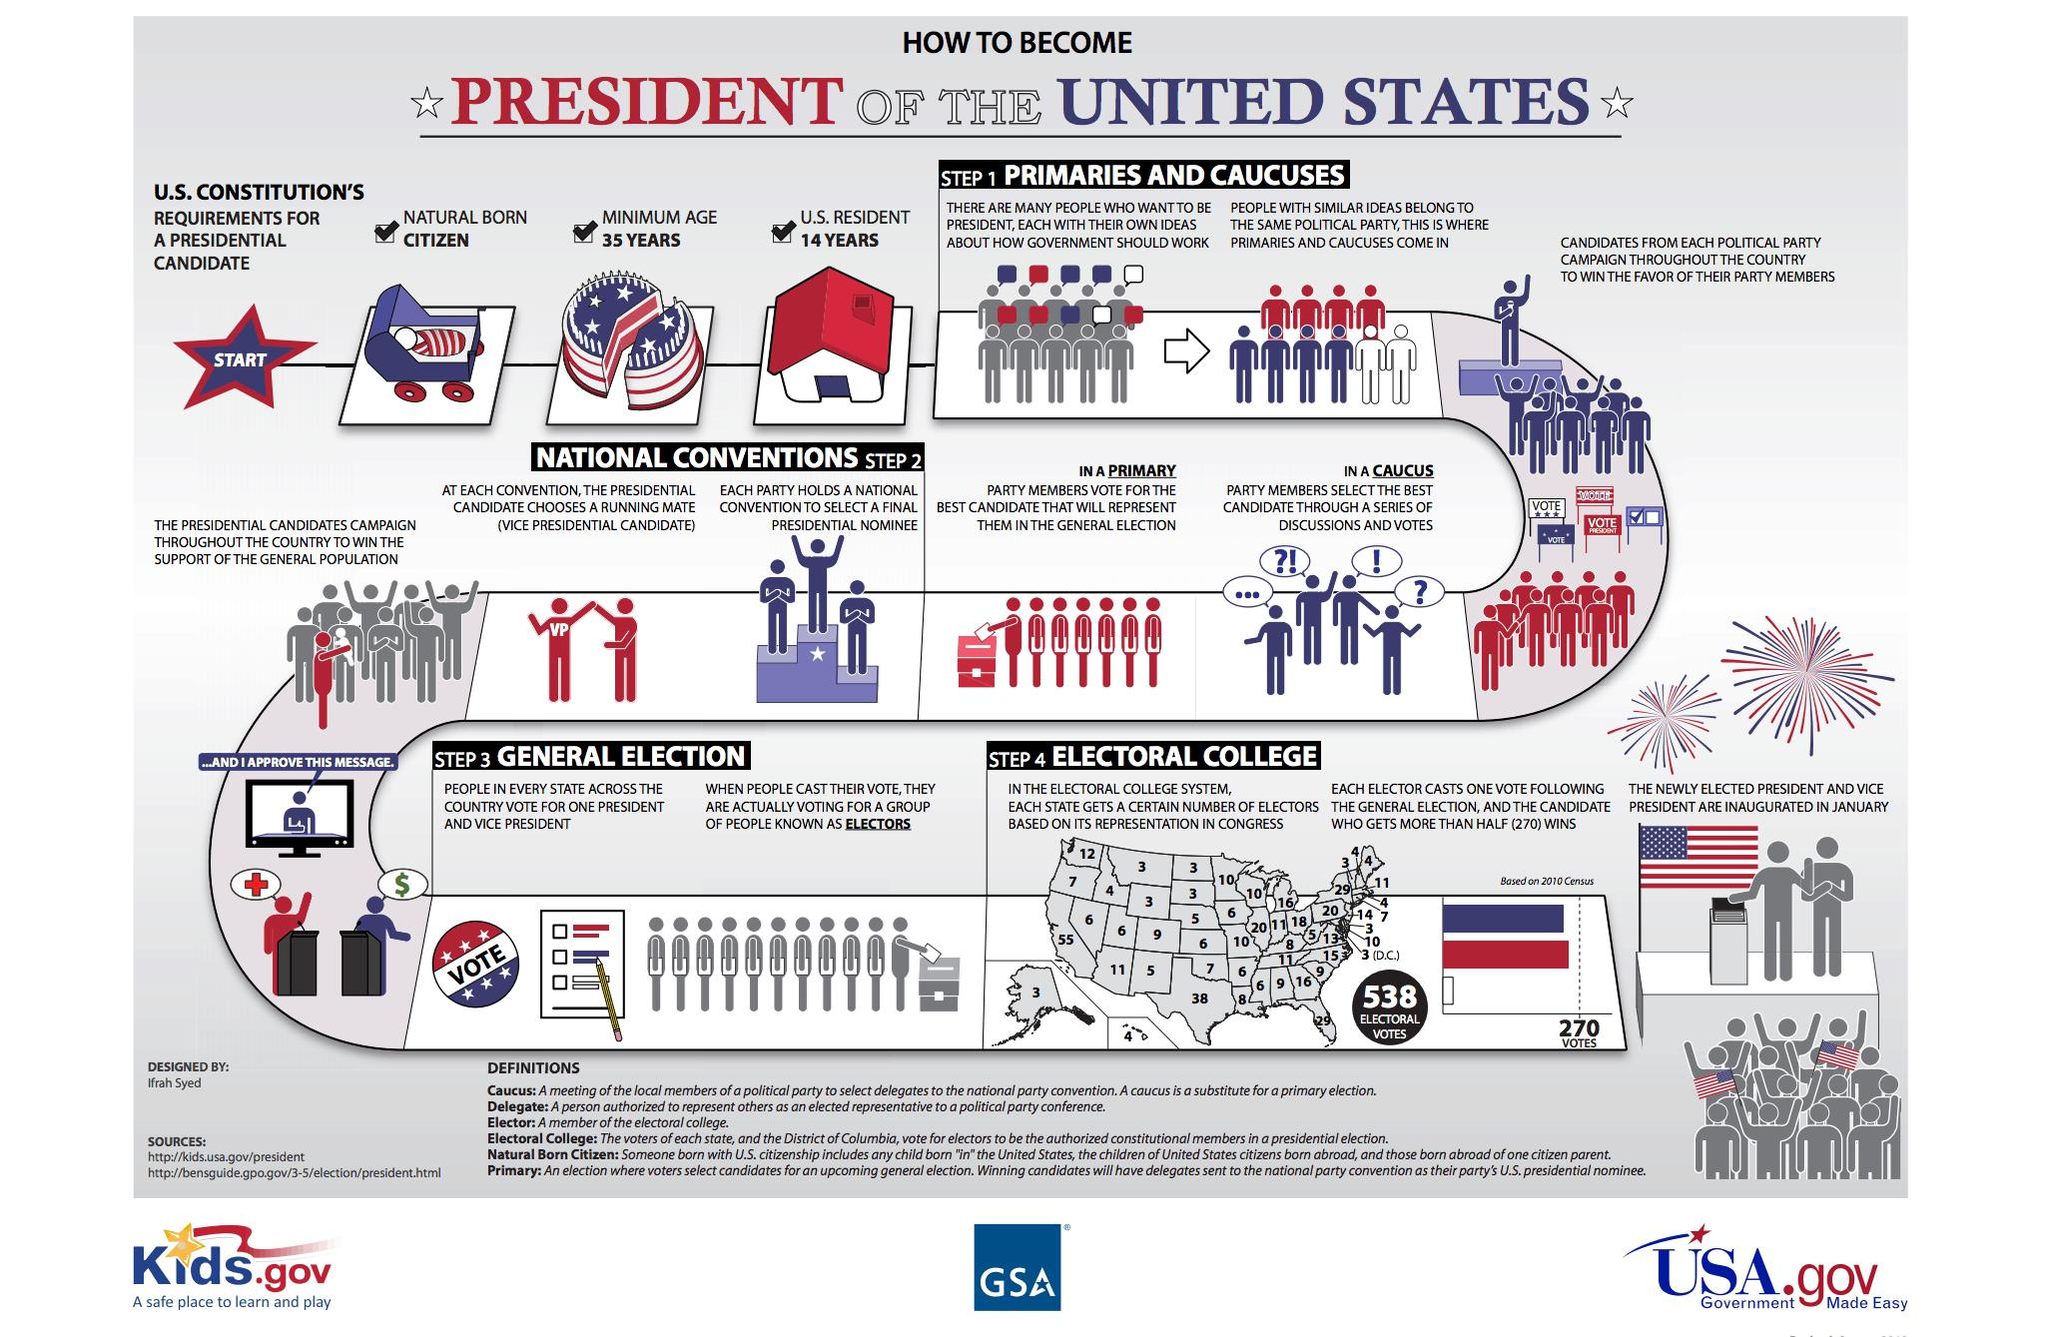Point out several critical features in this image. The third step in the election process is the general election. The final step in the election process is the electoral college. The United States Constitution mandates three requirements for a presidential candidate. The second step in the election process is the national conventions. The method(s) used to select the best candidate from a pool of candidates are chosen through a process that involves a decision made by two individuals. 